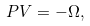Convert formula to latex. <formula><loc_0><loc_0><loc_500><loc_500>P V = - \Omega ,</formula> 